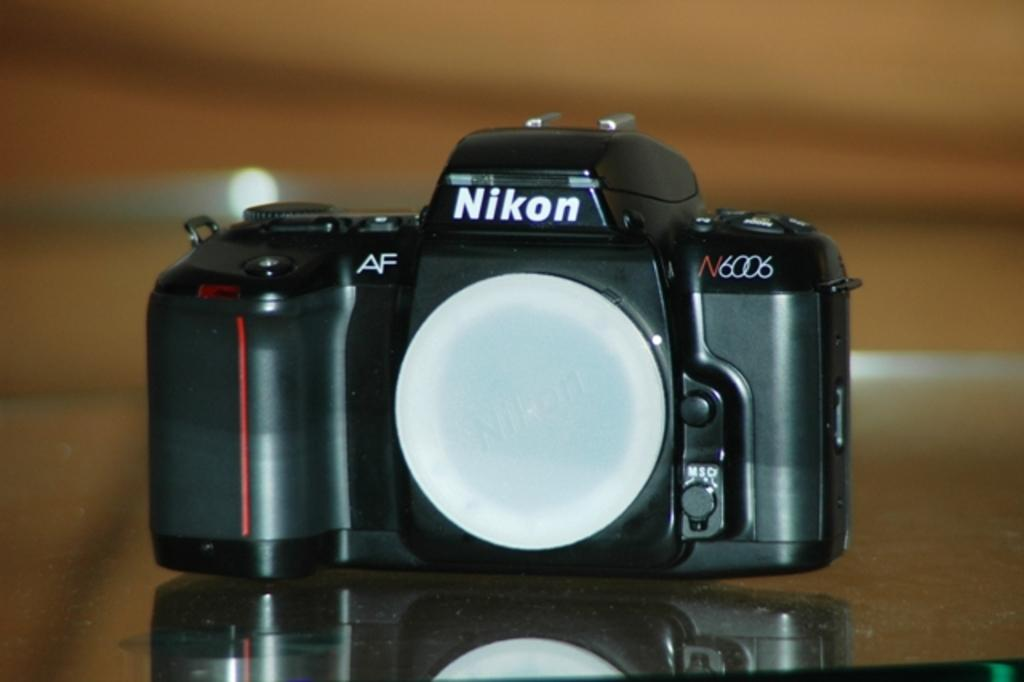<image>
Present a compact description of the photo's key features. A Nikon N6006 camera on a table with the lens removed. 